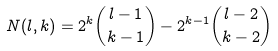<formula> <loc_0><loc_0><loc_500><loc_500>N ( l , k ) = 2 ^ { k } { l - 1 \choose k - 1 } - 2 ^ { k - 1 } { l - 2 \choose k - 2 }</formula> 